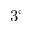<formula> <loc_0><loc_0><loc_500><loc_500>3 ^ { \circ }</formula> 